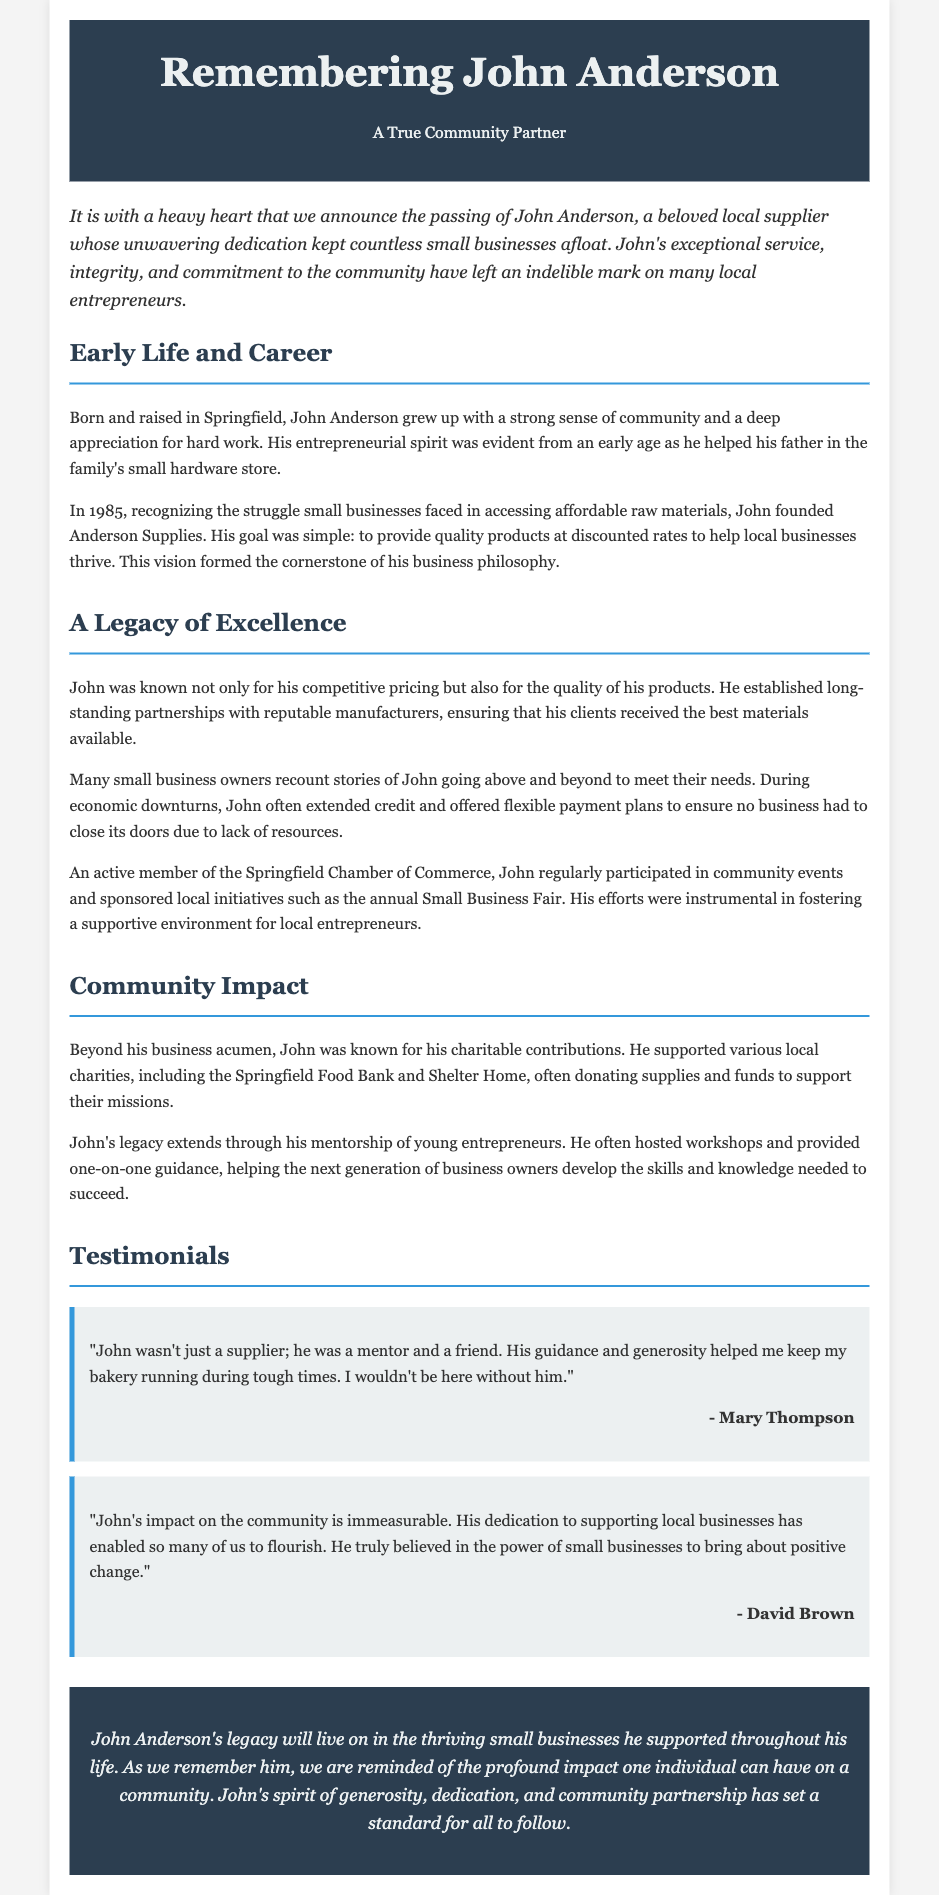What was John Anderson’s role in the community? John Anderson was a local supplier whose dedication kept small businesses afloat.
Answer: Local supplier In what year did John Anderson found Anderson Supplies? The document states that John founded Anderson Supplies in the year 1985.
Answer: 1985 What did John offer to small businesses to help them thrive? John provided quality products at discounted rates to help local businesses thrive.
Answer: Discounted rates Name one local charity supported by John Anderson. The document mentions the Springfield Food Bank as one of the charities John supported.
Answer: Springfield Food Bank How did John help during economic downturns? John often extended credit and offered flexible payment plans to ensure businesses had resources.
Answer: Extended credit What was John Anderson's philosophy regarding his business? His goal was to provide quality products at discounted rates to help local businesses thrive.
Answer: Quality products at discounted rates Which community events did John actively participate in? John regularly participated in community events and sponsored the annual Small Business Fair.
Answer: Annual Small Business Fair What type of guidance did John provide to young entrepreneurs? John hosted workshops and provided one-on-one guidance to help young entrepreneurs.
Answer: Workshops and one-on-one guidance Who stated, "John wasn't just a supplier; he was a mentor and a friend"? This quote was attributed to Mary Thompson in the testimonials section.
Answer: Mary Thompson 